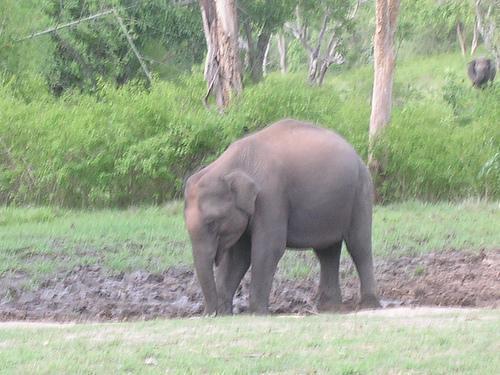How many elephants are in the picture?
Give a very brief answer. 2. 